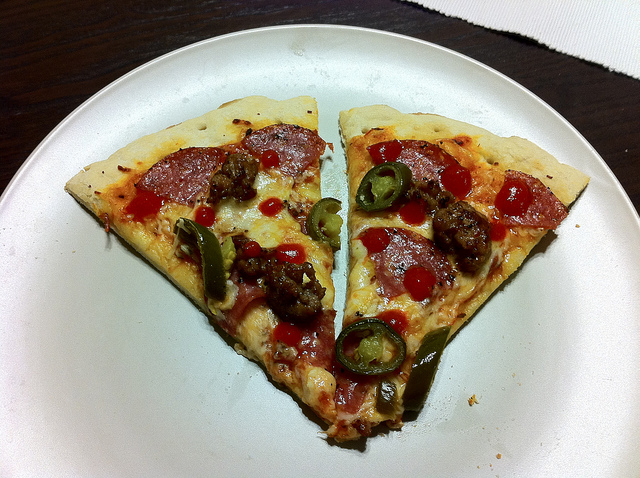<image>How many slices of the pizza have already been eaten? It is unknown how many slices of the pizza have already been eaten. How many slices of the pizza have already been eaten? I don't know how many slices of the pizza have already been eaten. 